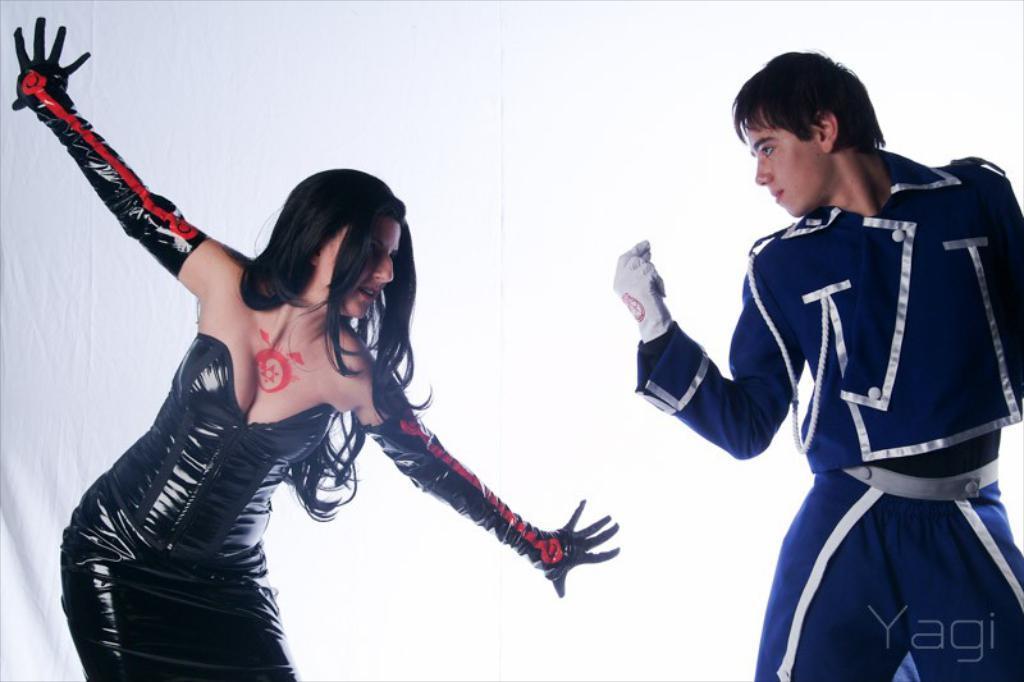How would you summarize this image in a sentence or two? In this image we can see woman and man. In the background there is curtain. 